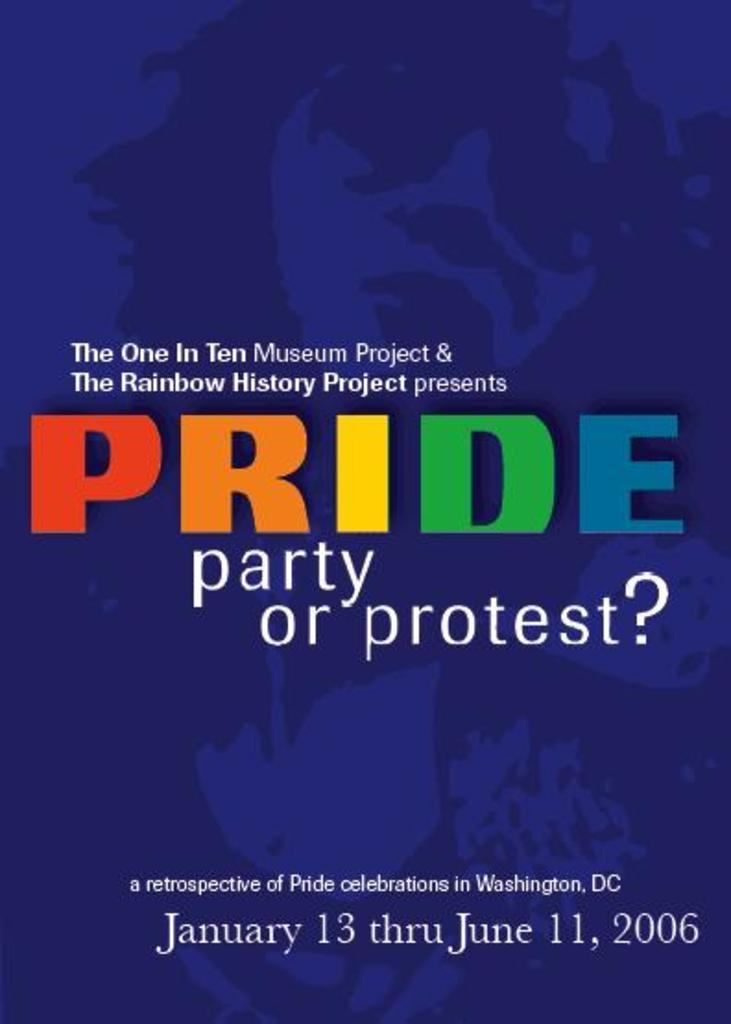Provide a one-sentence caption for the provided image. The museum is having an exhibit about Pride interests. 